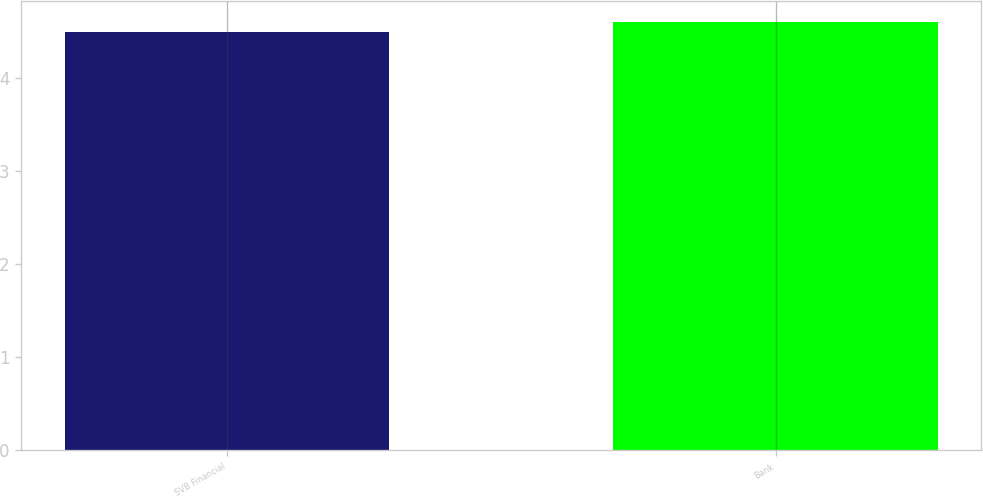Convert chart. <chart><loc_0><loc_0><loc_500><loc_500><bar_chart><fcel>SVB Financial<fcel>Bank<nl><fcel>4.5<fcel>4.6<nl></chart> 